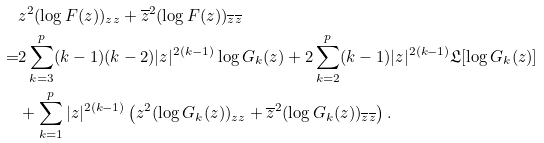<formula> <loc_0><loc_0><loc_500><loc_500>& z ^ { 2 } ( \log F ( z ) ) _ { z z } + \overline { z } ^ { 2 } ( \log F ( z ) ) _ { \overline { z } \overline { z } } \\ = & 2 \sum _ { k = 3 } ^ { p } ( k - 1 ) ( k - 2 ) | z | ^ { 2 ( k - 1 ) } \log G _ { k } ( z ) + 2 \sum _ { k = 2 } ^ { p } ( k - 1 ) | z | ^ { 2 ( k - 1 ) } \mathfrak { L } [ \log G _ { k } ( z ) ] \\ & + \sum _ { k = 1 } ^ { p } | z | ^ { 2 ( k - 1 ) } \left ( z ^ { 2 } ( \log G _ { k } ( z ) ) _ { z z } + \overline { z } ^ { 2 } ( \log G _ { k } ( z ) ) _ { \overline { z } \overline { z } } \right ) .</formula> 